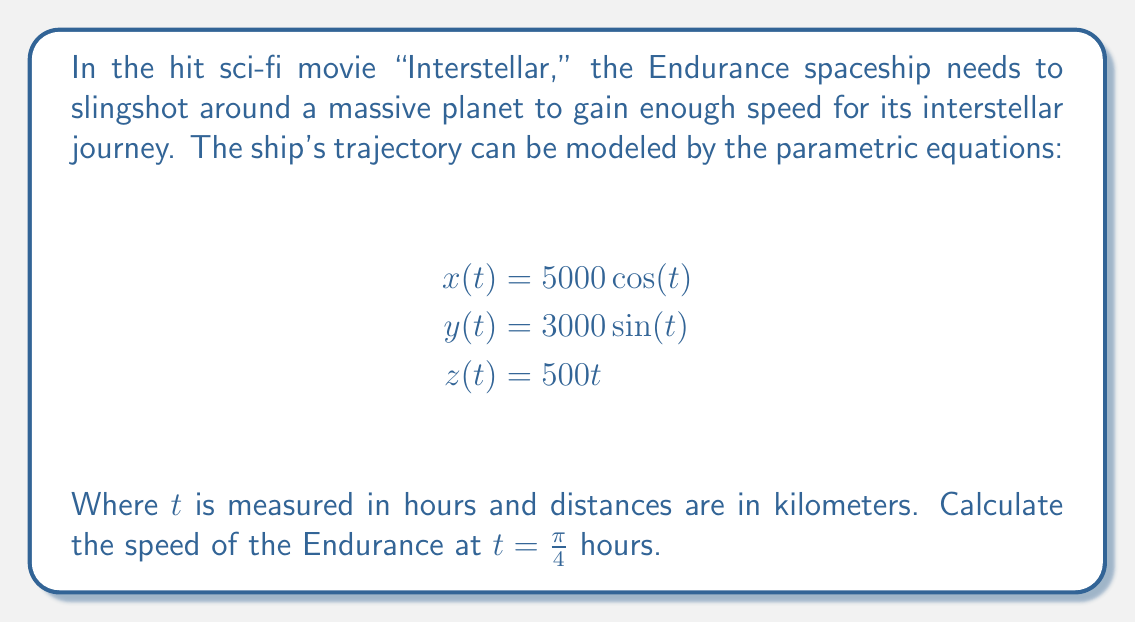Show me your answer to this math problem. To solve this problem, we'll use concepts from multivariable calculus, specifically parametric equations and vector-valued functions. Let's break it down step-by-step:

1) The position vector of the spaceship at any time $t$ is given by:

   $$\vec{r}(t) = \langle 5000 \cos(t), 3000 \sin(t), 500t \rangle$$

2) To find the velocity vector, we need to differentiate $\vec{r}(t)$ with respect to $t$:

   $$\vec{v}(t) = \frac{d\vec{r}}{dt} = \langle -5000 \sin(t), 3000 \cos(t), 500 \rangle$$

3) The speed is the magnitude of the velocity vector. We can calculate this using the formula:

   $$\text{speed} = \|\vec{v}(t)\| = \sqrt{v_x^2 + v_y^2 + v_z^2}$$

4) Substituting $t = \frac{\pi}{4}$ into our velocity vector:

   $$\vec{v}(\frac{\pi}{4}) = \langle -5000 \sin(\frac{\pi}{4}), 3000 \cos(\frac{\pi}{4}), 500 \rangle$$

5) Simplify using $\sin(\frac{\pi}{4}) = \cos(\frac{\pi}{4}) = \frac{\sqrt{2}}{2}$:

   $$\vec{v}(\frac{\pi}{4}) = \langle -5000 \cdot \frac{\sqrt{2}}{2}, 3000 \cdot \frac{\sqrt{2}}{2}, 500 \rangle$$
   
   $$= \langle -2500\sqrt{2}, 1500\sqrt{2}, 500 \rangle$$

6) Now, let's calculate the speed:

   $$\text{speed} = \sqrt{(-2500\sqrt{2})^2 + (1500\sqrt{2})^2 + 500^2}$$
   
   $$= \sqrt{12,500,000 + 4,500,000 + 250,000}$$
   
   $$= \sqrt{17,250,000}$$
   
   $$= 500\sqrt{69} \approx 4,155.78$$

Therefore, the speed of the Endurance at $t = \frac{\pi}{4}$ hours is approximately 4,155.78 km/h.
Answer: $500\sqrt{69}$ km/h or approximately 4,155.78 km/h 